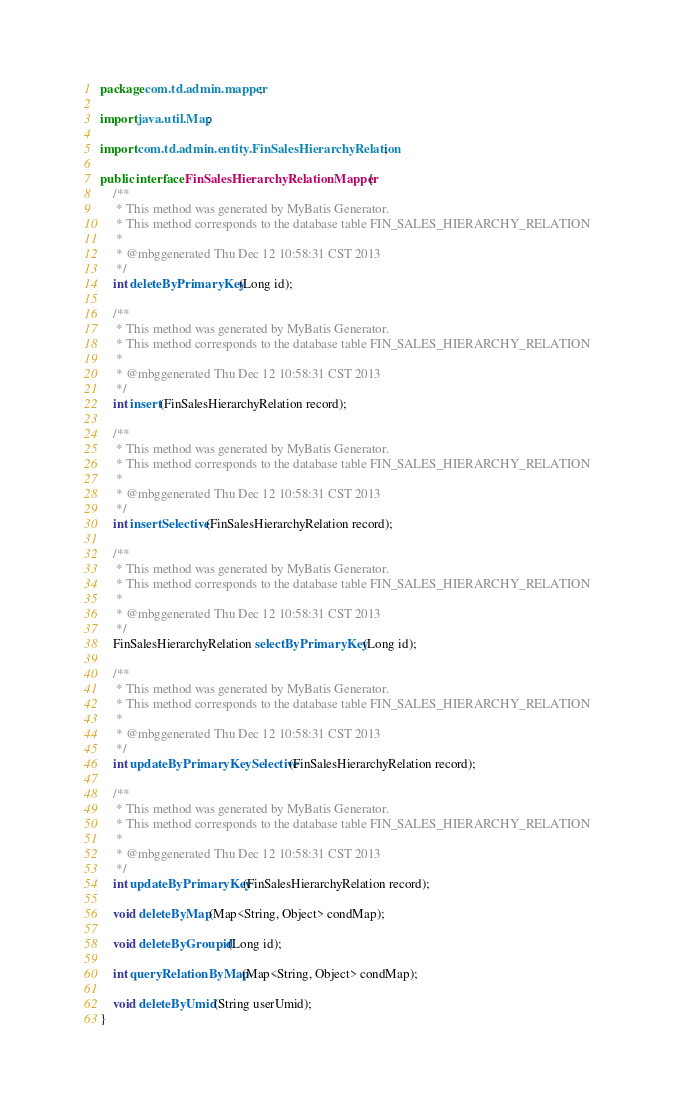<code> <loc_0><loc_0><loc_500><loc_500><_Java_>package com.td.admin.mapper;

import java.util.Map;

import com.td.admin.entity.FinSalesHierarchyRelation;

public interface FinSalesHierarchyRelationMapper {
    /**
     * This method was generated by MyBatis Generator.
     * This method corresponds to the database table FIN_SALES_HIERARCHY_RELATION
     *
     * @mbggenerated Thu Dec 12 10:58:31 CST 2013
     */
    int deleteByPrimaryKey(Long id);

    /**
     * This method was generated by MyBatis Generator.
     * This method corresponds to the database table FIN_SALES_HIERARCHY_RELATION
     *
     * @mbggenerated Thu Dec 12 10:58:31 CST 2013
     */
    int insert(FinSalesHierarchyRelation record);

    /**
     * This method was generated by MyBatis Generator.
     * This method corresponds to the database table FIN_SALES_HIERARCHY_RELATION
     *
     * @mbggenerated Thu Dec 12 10:58:31 CST 2013
     */
    int insertSelective(FinSalesHierarchyRelation record);

    /**
     * This method was generated by MyBatis Generator.
     * This method corresponds to the database table FIN_SALES_HIERARCHY_RELATION
     *
     * @mbggenerated Thu Dec 12 10:58:31 CST 2013
     */
    FinSalesHierarchyRelation selectByPrimaryKey(Long id);

    /**
     * This method was generated by MyBatis Generator.
     * This method corresponds to the database table FIN_SALES_HIERARCHY_RELATION
     *
     * @mbggenerated Thu Dec 12 10:58:31 CST 2013
     */
    int updateByPrimaryKeySelective(FinSalesHierarchyRelation record);

    /**
     * This method was generated by MyBatis Generator.
     * This method corresponds to the database table FIN_SALES_HIERARCHY_RELATION
     *
     * @mbggenerated Thu Dec 12 10:58:31 CST 2013
     */
    int updateByPrimaryKey(FinSalesHierarchyRelation record);

	void deleteByMap(Map<String, Object> condMap);

	void deleteByGroupid(Long id);

	int queryRelationByMap(Map<String, Object> condMap);

	void deleteByUmid(String userUmid);
}</code> 